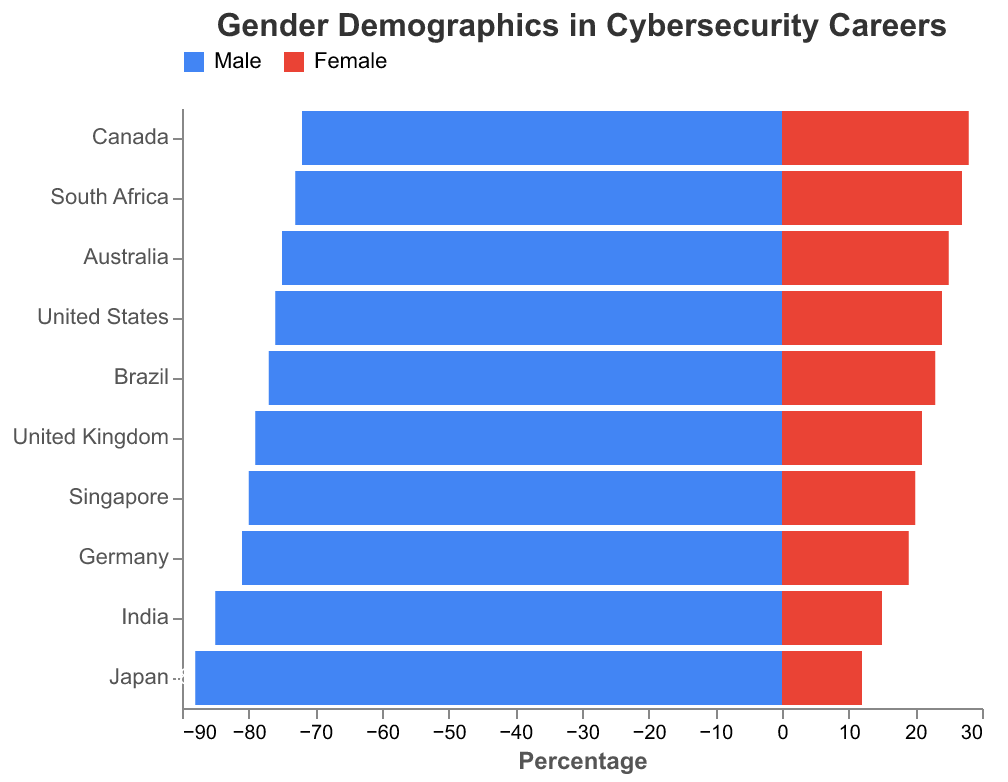What is the title of the figure? The title of the figure is prominently displayed at the top. It reads "Gender Demographics in Cybersecurity Careers".
Answer: Gender Demographics in Cybersecurity Careers Which country has the highest percentage of males in cybersecurity careers? The bar for males in Japan stretches the farthest to the left, indicating the highest percentage. It reaches 88%.
Answer: Japan Which country has the lowest percentage of females in cybersecurity careers? The bar for females in Japan is the shortest extending to the right, indicating the lowest percentage, which is 12%.
Answer: Japan How does the percentage of females in Canada compare to the percentage of females in Australia? The bar for females in Canada extends to 28%, while the bar for females in Australia extends to 25%. Therefore, Canada has a higher percentage of females in cybersecurity careers compared to Australia by 3%.
Answer: Canada has 3% more What is the combined percentage of males in cybersecurity careers in the United Kingdom and the United States? In the United Kingdom, the percentage of males is 79%, and in the United States, it is 76%. Adding these percentages, we get 79% + 76% = 155%.
Answer: 155% Which country has a more balanced gender distribution in cybersecurity careers, South Africa or Singapore? In South Africa, the male-to-female percentages are 73% and 27%, a difference of 46%. In Singapore, the male-to-female percentages are 80% and 20%, a difference of 60%. South Africa has a more balanced distribution
Answer: South Africa How does the gender distribution in cybersecurity careers in India compare to that in Germany? In India, males make up 85% and females 15%. In Germany, males make up 81% and females make up 19%. India has a 4% higher male percentage and a 4% lower female percentage compared to Germany.
Answer: India has 4% more males and 4% fewer females What is the average percentage of females in cybersecurity careers across all the listed countries? Adding the percentages of females in each country: 24 + 21 + 28 + 25 + 19 + 15 + 12 + 23 + 27 + 20 = 214. There are 10 countries, so the average is 214 / 10 = 21.4%.
Answer: 21.4% What range of percentages do the males in cybersecurity careers span across different countries? The smallest percentage for males is Canada with 72%, and the largest is Japan with 88%. This makes the range 88% - 72% = 16%.
Answer: 16% 